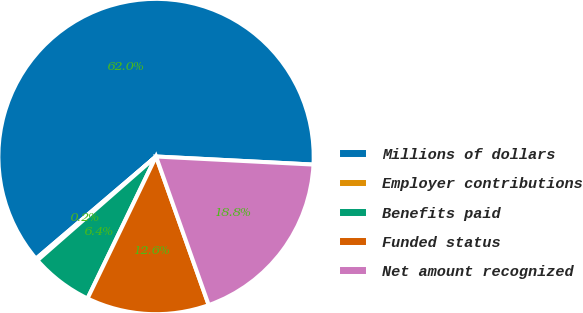<chart> <loc_0><loc_0><loc_500><loc_500><pie_chart><fcel>Millions of dollars<fcel>Employer contributions<fcel>Benefits paid<fcel>Funded status<fcel>Net amount recognized<nl><fcel>62.04%<fcel>0.22%<fcel>6.4%<fcel>12.58%<fcel>18.76%<nl></chart> 